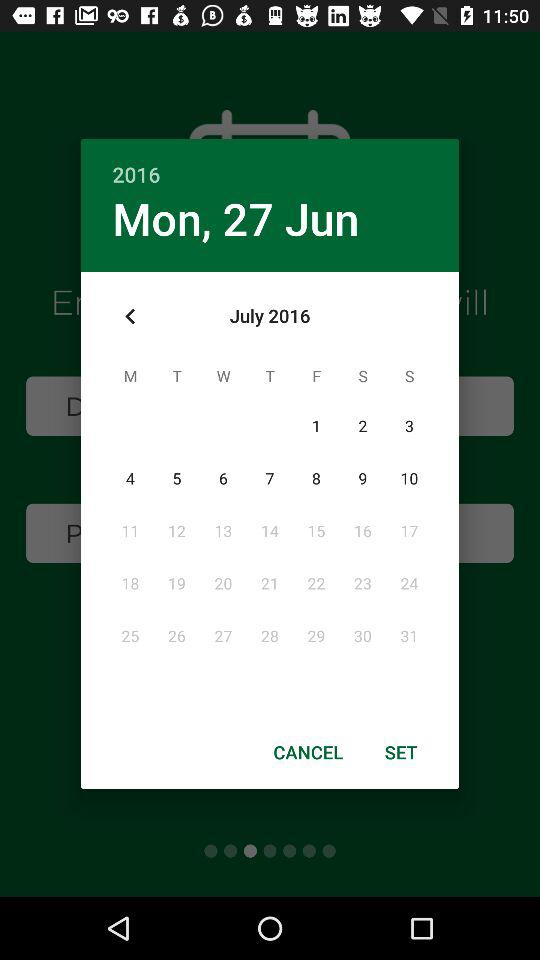What is the day on 27 Jun, 2016? The day is Monday. 